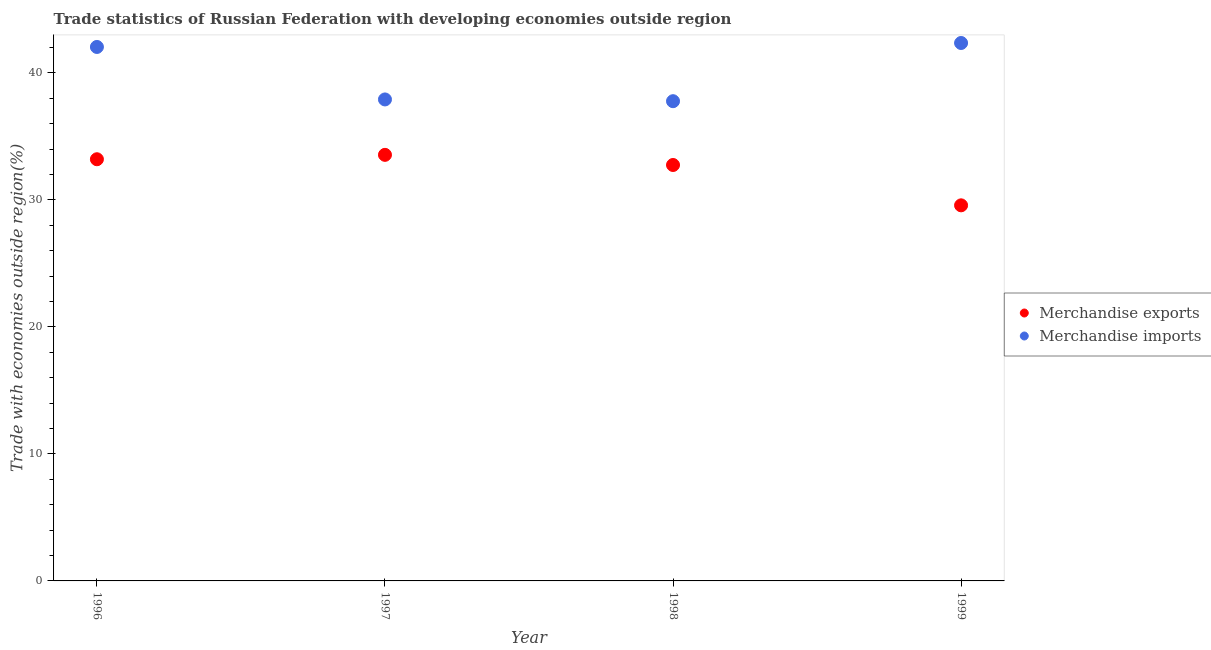Is the number of dotlines equal to the number of legend labels?
Ensure brevity in your answer.  Yes. What is the merchandise imports in 1996?
Keep it short and to the point. 42.04. Across all years, what is the maximum merchandise exports?
Offer a terse response. 33.54. Across all years, what is the minimum merchandise imports?
Your answer should be very brief. 37.77. In which year was the merchandise exports maximum?
Provide a succinct answer. 1997. What is the total merchandise imports in the graph?
Make the answer very short. 160.06. What is the difference between the merchandise imports in 1996 and that in 1999?
Give a very brief answer. -0.31. What is the difference between the merchandise imports in 1999 and the merchandise exports in 1996?
Keep it short and to the point. 9.15. What is the average merchandise exports per year?
Offer a very short reply. 32.26. In the year 1998, what is the difference between the merchandise imports and merchandise exports?
Make the answer very short. 5.02. In how many years, is the merchandise exports greater than 28 %?
Provide a succinct answer. 4. What is the ratio of the merchandise exports in 1997 to that in 1998?
Your answer should be very brief. 1.02. What is the difference between the highest and the second highest merchandise exports?
Make the answer very short. 0.35. What is the difference between the highest and the lowest merchandise exports?
Your response must be concise. 3.97. How many dotlines are there?
Offer a terse response. 2. How many years are there in the graph?
Ensure brevity in your answer.  4. Does the graph contain any zero values?
Your answer should be very brief. No. Does the graph contain grids?
Make the answer very short. No. Where does the legend appear in the graph?
Give a very brief answer. Center right. What is the title of the graph?
Give a very brief answer. Trade statistics of Russian Federation with developing economies outside region. Does "International Visitors" appear as one of the legend labels in the graph?
Ensure brevity in your answer.  No. What is the label or title of the Y-axis?
Your response must be concise. Trade with economies outside region(%). What is the Trade with economies outside region(%) in Merchandise exports in 1996?
Offer a very short reply. 33.2. What is the Trade with economies outside region(%) in Merchandise imports in 1996?
Offer a terse response. 42.04. What is the Trade with economies outside region(%) in Merchandise exports in 1997?
Your answer should be very brief. 33.54. What is the Trade with economies outside region(%) of Merchandise imports in 1997?
Offer a very short reply. 37.9. What is the Trade with economies outside region(%) in Merchandise exports in 1998?
Keep it short and to the point. 32.74. What is the Trade with economies outside region(%) of Merchandise imports in 1998?
Provide a succinct answer. 37.77. What is the Trade with economies outside region(%) of Merchandise exports in 1999?
Provide a short and direct response. 29.57. What is the Trade with economies outside region(%) in Merchandise imports in 1999?
Offer a terse response. 42.35. Across all years, what is the maximum Trade with economies outside region(%) of Merchandise exports?
Ensure brevity in your answer.  33.54. Across all years, what is the maximum Trade with economies outside region(%) of Merchandise imports?
Provide a succinct answer. 42.35. Across all years, what is the minimum Trade with economies outside region(%) in Merchandise exports?
Ensure brevity in your answer.  29.57. Across all years, what is the minimum Trade with economies outside region(%) of Merchandise imports?
Ensure brevity in your answer.  37.77. What is the total Trade with economies outside region(%) of Merchandise exports in the graph?
Offer a terse response. 129.05. What is the total Trade with economies outside region(%) in Merchandise imports in the graph?
Offer a very short reply. 160.06. What is the difference between the Trade with economies outside region(%) of Merchandise exports in 1996 and that in 1997?
Your answer should be compact. -0.35. What is the difference between the Trade with economies outside region(%) in Merchandise imports in 1996 and that in 1997?
Your response must be concise. 4.13. What is the difference between the Trade with economies outside region(%) of Merchandise exports in 1996 and that in 1998?
Provide a short and direct response. 0.45. What is the difference between the Trade with economies outside region(%) in Merchandise imports in 1996 and that in 1998?
Ensure brevity in your answer.  4.27. What is the difference between the Trade with economies outside region(%) in Merchandise exports in 1996 and that in 1999?
Make the answer very short. 3.63. What is the difference between the Trade with economies outside region(%) in Merchandise imports in 1996 and that in 1999?
Your response must be concise. -0.31. What is the difference between the Trade with economies outside region(%) in Merchandise exports in 1997 and that in 1998?
Give a very brief answer. 0.8. What is the difference between the Trade with economies outside region(%) in Merchandise imports in 1997 and that in 1998?
Provide a short and direct response. 0.14. What is the difference between the Trade with economies outside region(%) of Merchandise exports in 1997 and that in 1999?
Keep it short and to the point. 3.97. What is the difference between the Trade with economies outside region(%) in Merchandise imports in 1997 and that in 1999?
Your answer should be very brief. -4.44. What is the difference between the Trade with economies outside region(%) in Merchandise exports in 1998 and that in 1999?
Provide a short and direct response. 3.18. What is the difference between the Trade with economies outside region(%) in Merchandise imports in 1998 and that in 1999?
Your answer should be compact. -4.58. What is the difference between the Trade with economies outside region(%) in Merchandise exports in 1996 and the Trade with economies outside region(%) in Merchandise imports in 1997?
Offer a very short reply. -4.71. What is the difference between the Trade with economies outside region(%) of Merchandise exports in 1996 and the Trade with economies outside region(%) of Merchandise imports in 1998?
Your answer should be very brief. -4.57. What is the difference between the Trade with economies outside region(%) of Merchandise exports in 1996 and the Trade with economies outside region(%) of Merchandise imports in 1999?
Keep it short and to the point. -9.15. What is the difference between the Trade with economies outside region(%) in Merchandise exports in 1997 and the Trade with economies outside region(%) in Merchandise imports in 1998?
Give a very brief answer. -4.22. What is the difference between the Trade with economies outside region(%) of Merchandise exports in 1997 and the Trade with economies outside region(%) of Merchandise imports in 1999?
Offer a terse response. -8.81. What is the difference between the Trade with economies outside region(%) in Merchandise exports in 1998 and the Trade with economies outside region(%) in Merchandise imports in 1999?
Keep it short and to the point. -9.6. What is the average Trade with economies outside region(%) of Merchandise exports per year?
Make the answer very short. 32.26. What is the average Trade with economies outside region(%) in Merchandise imports per year?
Offer a terse response. 40.01. In the year 1996, what is the difference between the Trade with economies outside region(%) of Merchandise exports and Trade with economies outside region(%) of Merchandise imports?
Your response must be concise. -8.84. In the year 1997, what is the difference between the Trade with economies outside region(%) of Merchandise exports and Trade with economies outside region(%) of Merchandise imports?
Give a very brief answer. -4.36. In the year 1998, what is the difference between the Trade with economies outside region(%) of Merchandise exports and Trade with economies outside region(%) of Merchandise imports?
Offer a terse response. -5.02. In the year 1999, what is the difference between the Trade with economies outside region(%) in Merchandise exports and Trade with economies outside region(%) in Merchandise imports?
Provide a succinct answer. -12.78. What is the ratio of the Trade with economies outside region(%) in Merchandise exports in 1996 to that in 1997?
Make the answer very short. 0.99. What is the ratio of the Trade with economies outside region(%) in Merchandise imports in 1996 to that in 1997?
Your response must be concise. 1.11. What is the ratio of the Trade with economies outside region(%) of Merchandise exports in 1996 to that in 1998?
Keep it short and to the point. 1.01. What is the ratio of the Trade with economies outside region(%) of Merchandise imports in 1996 to that in 1998?
Your answer should be compact. 1.11. What is the ratio of the Trade with economies outside region(%) in Merchandise exports in 1996 to that in 1999?
Provide a short and direct response. 1.12. What is the ratio of the Trade with economies outside region(%) of Merchandise exports in 1997 to that in 1998?
Provide a short and direct response. 1.02. What is the ratio of the Trade with economies outside region(%) of Merchandise imports in 1997 to that in 1998?
Your answer should be compact. 1. What is the ratio of the Trade with economies outside region(%) of Merchandise exports in 1997 to that in 1999?
Offer a terse response. 1.13. What is the ratio of the Trade with economies outside region(%) in Merchandise imports in 1997 to that in 1999?
Give a very brief answer. 0.9. What is the ratio of the Trade with economies outside region(%) of Merchandise exports in 1998 to that in 1999?
Your response must be concise. 1.11. What is the ratio of the Trade with economies outside region(%) in Merchandise imports in 1998 to that in 1999?
Provide a succinct answer. 0.89. What is the difference between the highest and the second highest Trade with economies outside region(%) in Merchandise exports?
Make the answer very short. 0.35. What is the difference between the highest and the second highest Trade with economies outside region(%) in Merchandise imports?
Offer a terse response. 0.31. What is the difference between the highest and the lowest Trade with economies outside region(%) in Merchandise exports?
Offer a very short reply. 3.97. What is the difference between the highest and the lowest Trade with economies outside region(%) in Merchandise imports?
Your answer should be very brief. 4.58. 